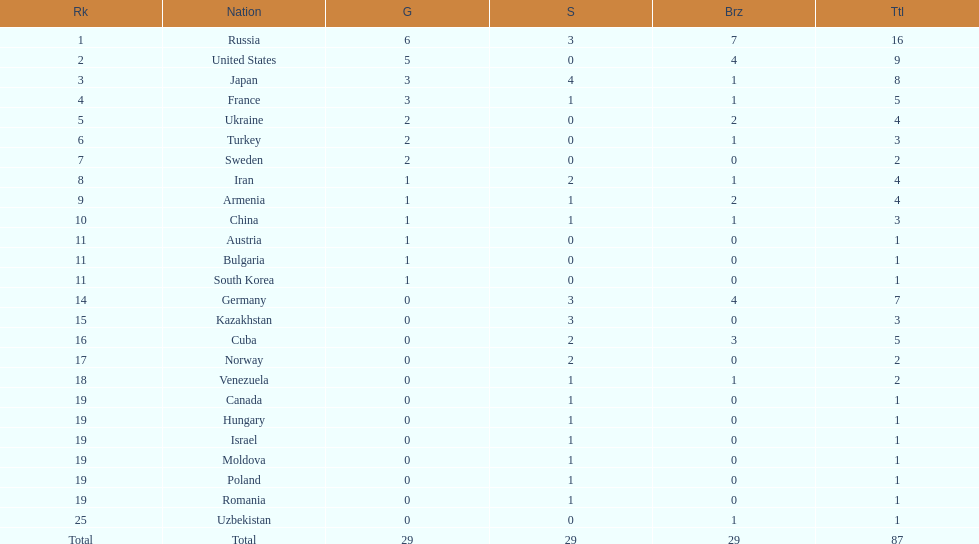Who won more gold medals than the united states? Russia. 